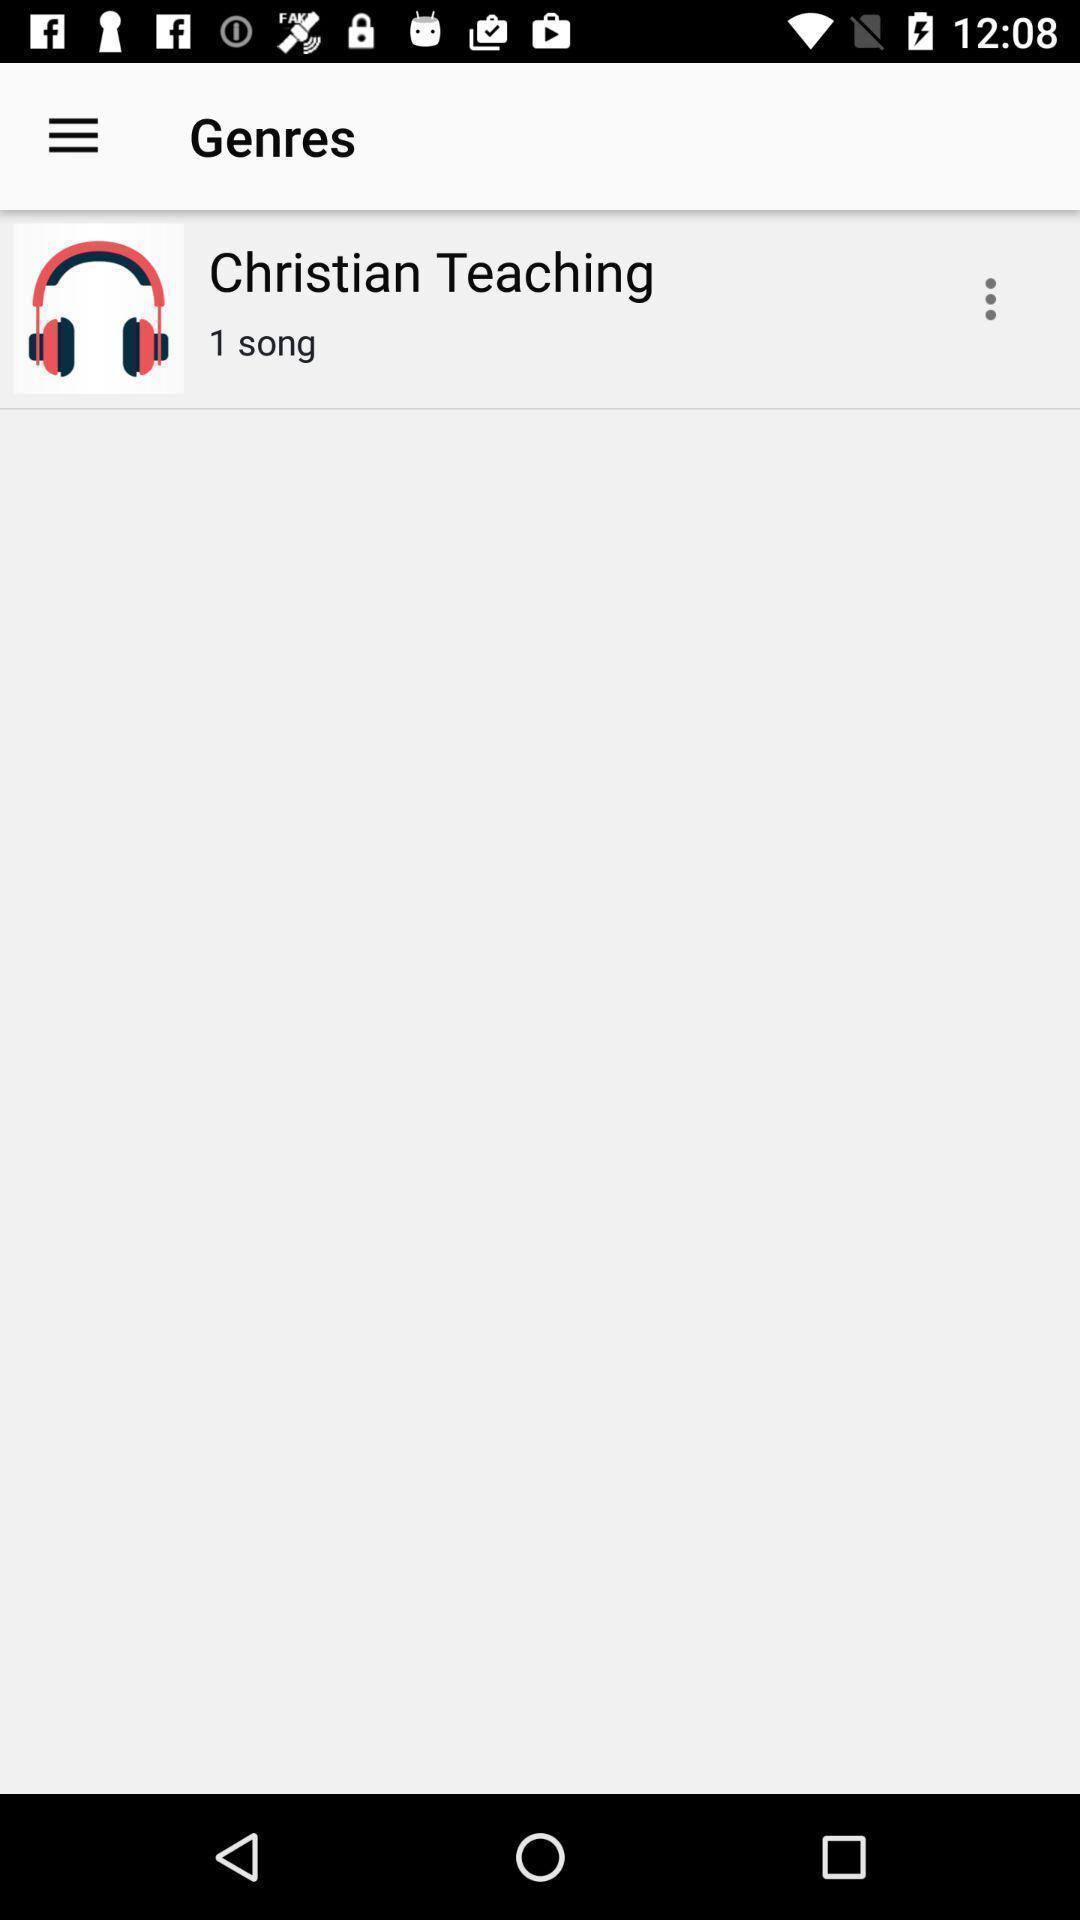Give me a narrative description of this picture. Songs page in a christian music app. 